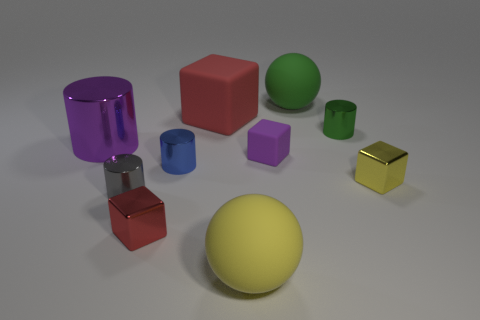Subtract all blue cylinders. How many cylinders are left? 3 Subtract all red blocks. How many blocks are left? 2 Subtract 2 blocks. How many blocks are left? 2 Add 6 tiny green rubber balls. How many tiny green rubber balls exist? 6 Subtract 0 blue blocks. How many objects are left? 10 Subtract all cylinders. How many objects are left? 6 Subtract all gray blocks. Subtract all purple cylinders. How many blocks are left? 4 Subtract all cyan spheres. How many purple blocks are left? 1 Subtract all brown objects. Subtract all yellow rubber spheres. How many objects are left? 9 Add 4 gray metal cylinders. How many gray metal cylinders are left? 5 